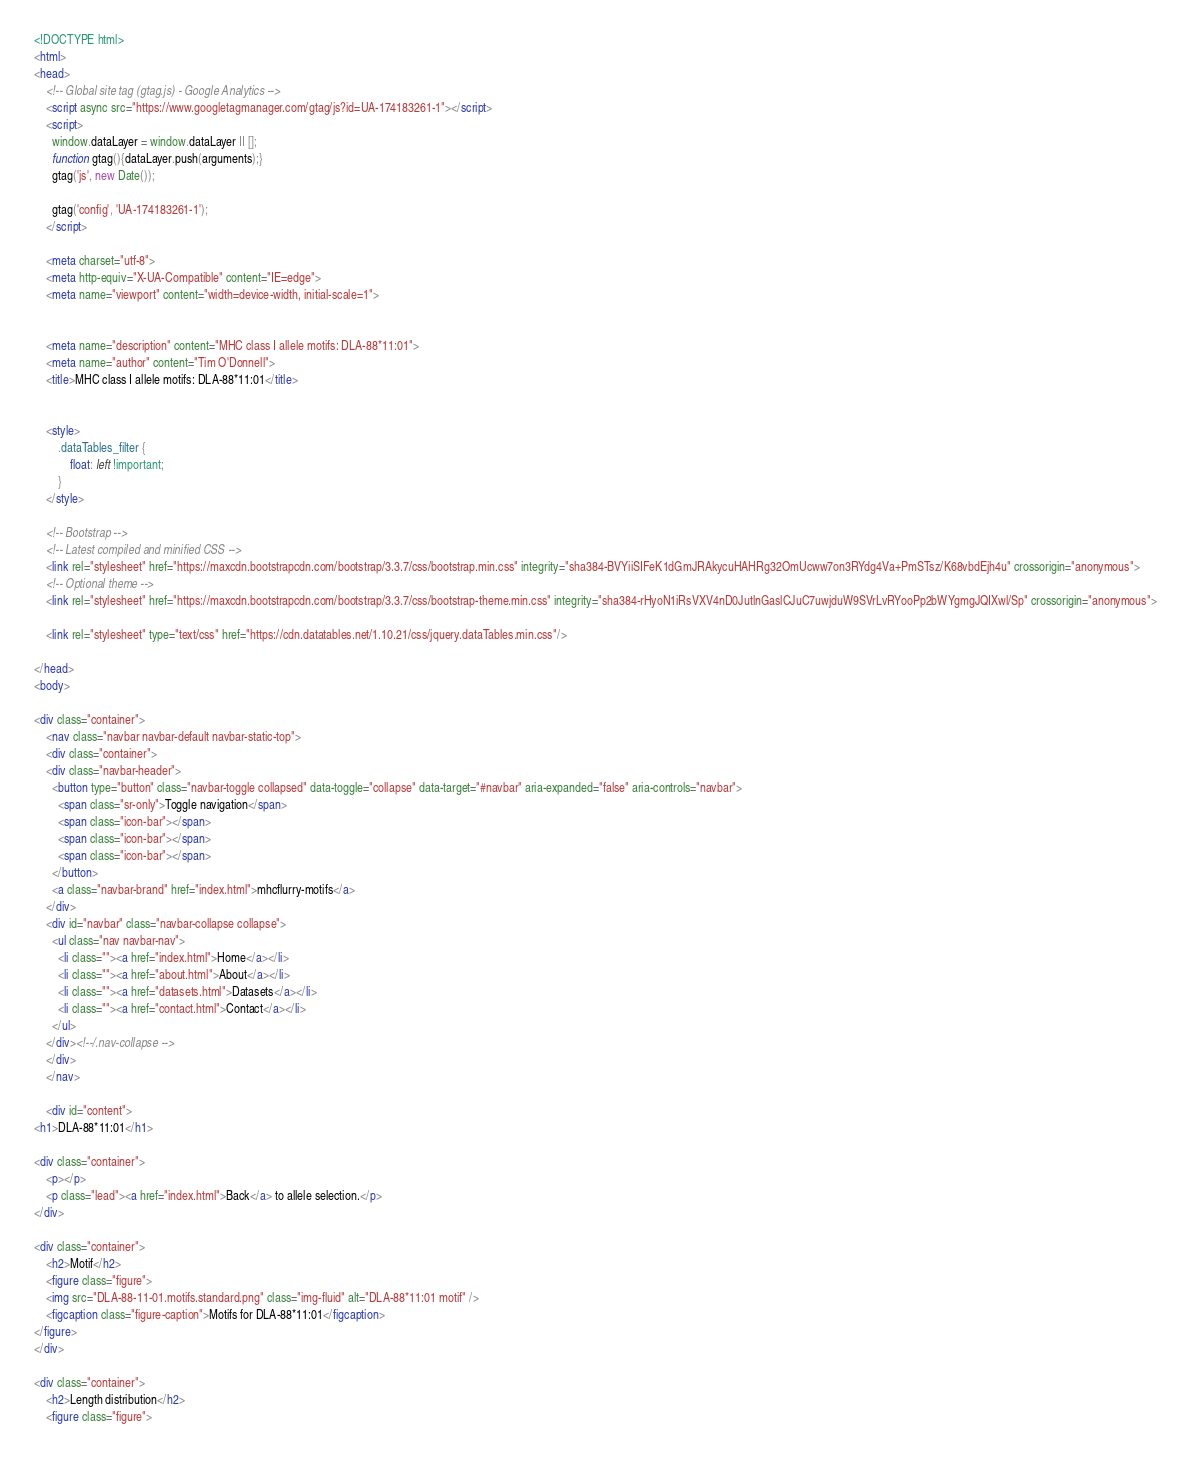<code> <loc_0><loc_0><loc_500><loc_500><_HTML_><!DOCTYPE html>
<html>
<head>
    <!-- Global site tag (gtag.js) - Google Analytics -->
    <script async src="https://www.googletagmanager.com/gtag/js?id=UA-174183261-1"></script>
    <script>
      window.dataLayer = window.dataLayer || [];
      function gtag(){dataLayer.push(arguments);}
      gtag('js', new Date());

      gtag('config', 'UA-174183261-1');
    </script>

    <meta charset="utf-8">
    <meta http-equiv="X-UA-Compatible" content="IE=edge">
    <meta name="viewport" content="width=device-width, initial-scale=1">

    
    <meta name="description" content="MHC class I allele motifs: DLA-88*11:01">
    <meta name="author" content="Tim O'Donnell">
    <title>MHC class I allele motifs: DLA-88*11:01</title>
    

    <style>
        .dataTables_filter {
            float: left !important;
        }
    </style>

    <!-- Bootstrap -->
    <!-- Latest compiled and minified CSS -->
    <link rel="stylesheet" href="https://maxcdn.bootstrapcdn.com/bootstrap/3.3.7/css/bootstrap.min.css" integrity="sha384-BVYiiSIFeK1dGmJRAkycuHAHRg32OmUcww7on3RYdg4Va+PmSTsz/K68vbdEjh4u" crossorigin="anonymous">
    <!-- Optional theme -->
    <link rel="stylesheet" href="https://maxcdn.bootstrapcdn.com/bootstrap/3.3.7/css/bootstrap-theme.min.css" integrity="sha384-rHyoN1iRsVXV4nD0JutlnGaslCJuC7uwjduW9SVrLvRYooPp2bWYgmgJQIXwl/Sp" crossorigin="anonymous">

    <link rel="stylesheet" type="text/css" href="https://cdn.datatables.net/1.10.21/css/jquery.dataTables.min.css"/>

</head>
<body>

<div class="container">
    <nav class="navbar navbar-default navbar-static-top">
    <div class="container">
    <div class="navbar-header">
      <button type="button" class="navbar-toggle collapsed" data-toggle="collapse" data-target="#navbar" aria-expanded="false" aria-controls="navbar">
        <span class="sr-only">Toggle navigation</span>
        <span class="icon-bar"></span>
        <span class="icon-bar"></span>
        <span class="icon-bar"></span>
      </button>
      <a class="navbar-brand" href="index.html">mhcflurry-motifs</a>
    </div>
    <div id="navbar" class="navbar-collapse collapse">
      <ul class="nav navbar-nav">
        <li class=""><a href="index.html">Home</a></li>
        <li class=""><a href="about.html">About</a></li>
        <li class=""><a href="datasets.html">Datasets</a></li>
        <li class=""><a href="contact.html">Contact</a></li>
      </ul>
    </div><!--/.nav-collapse -->
    </div>
    </nav>

    <div id="content">
<h1>DLA-88*11:01</h1>

<div class="container">
    <p></p>
    <p class="lead"><a href="index.html">Back</a> to allele selection.</p>
</div>

<div class="container">
    <h2>Motif</h2>
    <figure class="figure">
    <img src="DLA-88-11-01.motifs.standard.png" class="img-fluid" alt="DLA-88*11:01 motif" />
    <figcaption class="figure-caption">Motifs for DLA-88*11:01</figcaption>
</figure>
</div>

<div class="container">
    <h2>Length distribution</h2>
    <figure class="figure"></code> 